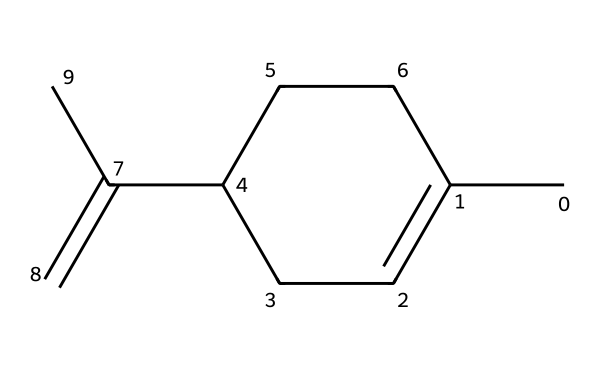What is the primary functional group present in limonene? Limonene has a double bond in its structure, which indicates the presence of an alkene functional group.
Answer: alkene How many carbon atoms are in limonene? By analyzing the SMILES representation, there are 10 carbon atoms present in the structure of limonene.
Answer: 10 How many hydrogen atoms are linked to the carbon chain in limonene? The structure shows that limonene has 16 hydrogen atoms connected to its carbon framework, following the tetravalency of carbon.
Answer: 16 What type of compound is limonene categorized as? Limonene is categorized as a terpene, which is characterized by its multi-membered hydrocarbons often derived from plant sources.
Answer: terpene What is the molecular formula of limonene? From counting the carbon and hydrogen atoms in limonene's structure, the molecular formula can be derived as C10H16.
Answer: C10H16 What characteristic does the presence of the double bond in limonene impart? The double bond gives limonene its unsaturated character, which contributes to its reactivity and distinct citrus aroma found in cleaning products.
Answer: unsaturated 